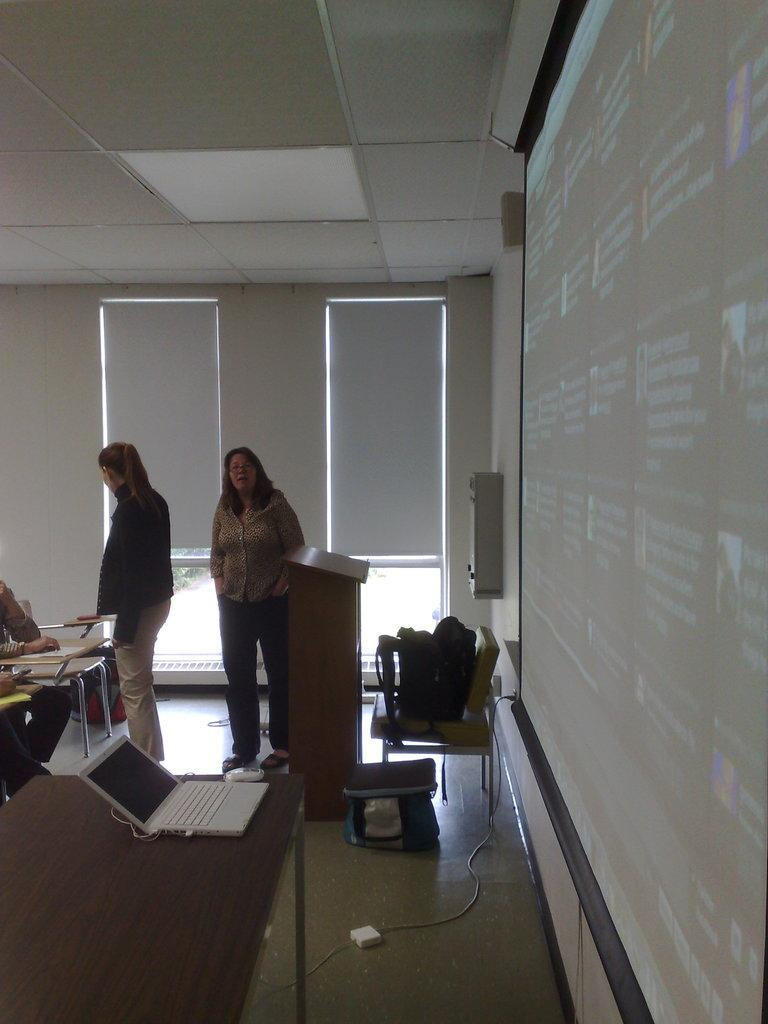How many women are in the image? There are two women in the image. Where are the women located in the image? The women are standing in the top center of the image. What type of furniture is in the image? There is a wooden table in the image. What electronic device is on the wooden table? A laptop is present on the wooden table. What can be seen on the screen in the image? There is a screen visible in the image. What type of toy is the government using to control the screen in the image? There is no toy or government present in the image, and therefore no such control can be observed. 